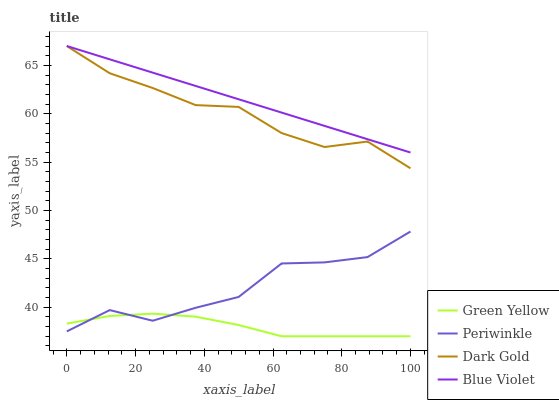Does Green Yellow have the minimum area under the curve?
Answer yes or no. Yes. Does Blue Violet have the maximum area under the curve?
Answer yes or no. Yes. Does Periwinkle have the minimum area under the curve?
Answer yes or no. No. Does Periwinkle have the maximum area under the curve?
Answer yes or no. No. Is Blue Violet the smoothest?
Answer yes or no. Yes. Is Periwinkle the roughest?
Answer yes or no. Yes. Is Periwinkle the smoothest?
Answer yes or no. No. Is Blue Violet the roughest?
Answer yes or no. No. Does Green Yellow have the lowest value?
Answer yes or no. Yes. Does Periwinkle have the lowest value?
Answer yes or no. No. Does Dark Gold have the highest value?
Answer yes or no. Yes. Does Periwinkle have the highest value?
Answer yes or no. No. Is Periwinkle less than Dark Gold?
Answer yes or no. Yes. Is Blue Violet greater than Periwinkle?
Answer yes or no. Yes. Does Dark Gold intersect Blue Violet?
Answer yes or no. Yes. Is Dark Gold less than Blue Violet?
Answer yes or no. No. Is Dark Gold greater than Blue Violet?
Answer yes or no. No. Does Periwinkle intersect Dark Gold?
Answer yes or no. No. 